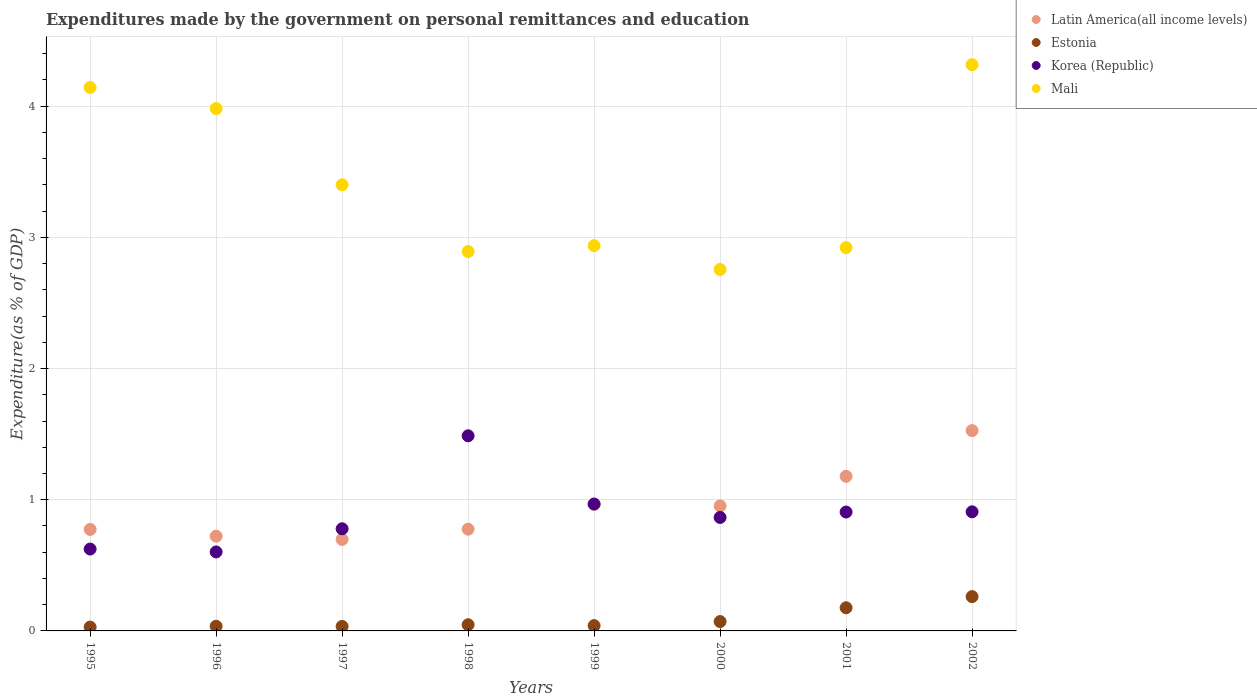How many different coloured dotlines are there?
Make the answer very short. 4. Is the number of dotlines equal to the number of legend labels?
Provide a short and direct response. Yes. What is the expenditures made by the government on personal remittances and education in Estonia in 1996?
Provide a short and direct response. 0.04. Across all years, what is the maximum expenditures made by the government on personal remittances and education in Mali?
Offer a terse response. 4.32. Across all years, what is the minimum expenditures made by the government on personal remittances and education in Estonia?
Ensure brevity in your answer.  0.03. In which year was the expenditures made by the government on personal remittances and education in Estonia minimum?
Offer a very short reply. 1995. What is the total expenditures made by the government on personal remittances and education in Estonia in the graph?
Your answer should be very brief. 0.7. What is the difference between the expenditures made by the government on personal remittances and education in Mali in 1999 and that in 2000?
Your response must be concise. 0.18. What is the difference between the expenditures made by the government on personal remittances and education in Estonia in 2002 and the expenditures made by the government on personal remittances and education in Mali in 1999?
Your response must be concise. -2.68. What is the average expenditures made by the government on personal remittances and education in Korea (Republic) per year?
Give a very brief answer. 0.89. In the year 1996, what is the difference between the expenditures made by the government on personal remittances and education in Latin America(all income levels) and expenditures made by the government on personal remittances and education in Estonia?
Your response must be concise. 0.69. In how many years, is the expenditures made by the government on personal remittances and education in Mali greater than 2.8 %?
Make the answer very short. 7. What is the ratio of the expenditures made by the government on personal remittances and education in Mali in 1996 to that in 2002?
Make the answer very short. 0.92. What is the difference between the highest and the second highest expenditures made by the government on personal remittances and education in Korea (Republic)?
Offer a terse response. 0.52. What is the difference between the highest and the lowest expenditures made by the government on personal remittances and education in Estonia?
Provide a succinct answer. 0.23. Is it the case that in every year, the sum of the expenditures made by the government on personal remittances and education in Korea (Republic) and expenditures made by the government on personal remittances and education in Mali  is greater than the sum of expenditures made by the government on personal remittances and education in Latin America(all income levels) and expenditures made by the government on personal remittances and education in Estonia?
Ensure brevity in your answer.  Yes. Does the expenditures made by the government on personal remittances and education in Korea (Republic) monotonically increase over the years?
Provide a short and direct response. No. Is the expenditures made by the government on personal remittances and education in Estonia strictly greater than the expenditures made by the government on personal remittances and education in Korea (Republic) over the years?
Give a very brief answer. No. How many years are there in the graph?
Your answer should be very brief. 8. What is the difference between two consecutive major ticks on the Y-axis?
Offer a terse response. 1. Does the graph contain grids?
Provide a short and direct response. Yes. Where does the legend appear in the graph?
Your response must be concise. Top right. How many legend labels are there?
Provide a short and direct response. 4. What is the title of the graph?
Your answer should be compact. Expenditures made by the government on personal remittances and education. Does "Libya" appear as one of the legend labels in the graph?
Offer a terse response. No. What is the label or title of the Y-axis?
Offer a terse response. Expenditure(as % of GDP). What is the Expenditure(as % of GDP) of Latin America(all income levels) in 1995?
Give a very brief answer. 0.77. What is the Expenditure(as % of GDP) of Estonia in 1995?
Offer a very short reply. 0.03. What is the Expenditure(as % of GDP) in Korea (Republic) in 1995?
Give a very brief answer. 0.62. What is the Expenditure(as % of GDP) in Mali in 1995?
Your answer should be compact. 4.14. What is the Expenditure(as % of GDP) of Latin America(all income levels) in 1996?
Give a very brief answer. 0.72. What is the Expenditure(as % of GDP) of Estonia in 1996?
Your response must be concise. 0.04. What is the Expenditure(as % of GDP) in Korea (Republic) in 1996?
Your answer should be very brief. 0.6. What is the Expenditure(as % of GDP) of Mali in 1996?
Provide a short and direct response. 3.98. What is the Expenditure(as % of GDP) of Latin America(all income levels) in 1997?
Your answer should be compact. 0.7. What is the Expenditure(as % of GDP) of Estonia in 1997?
Your answer should be compact. 0.03. What is the Expenditure(as % of GDP) of Korea (Republic) in 1997?
Provide a succinct answer. 0.78. What is the Expenditure(as % of GDP) of Mali in 1997?
Offer a very short reply. 3.4. What is the Expenditure(as % of GDP) in Latin America(all income levels) in 1998?
Give a very brief answer. 0.78. What is the Expenditure(as % of GDP) of Estonia in 1998?
Provide a short and direct response. 0.05. What is the Expenditure(as % of GDP) in Korea (Republic) in 1998?
Keep it short and to the point. 1.49. What is the Expenditure(as % of GDP) of Mali in 1998?
Give a very brief answer. 2.89. What is the Expenditure(as % of GDP) in Latin America(all income levels) in 1999?
Your answer should be compact. 0.96. What is the Expenditure(as % of GDP) of Estonia in 1999?
Provide a short and direct response. 0.04. What is the Expenditure(as % of GDP) of Korea (Republic) in 1999?
Ensure brevity in your answer.  0.97. What is the Expenditure(as % of GDP) of Mali in 1999?
Keep it short and to the point. 2.94. What is the Expenditure(as % of GDP) in Latin America(all income levels) in 2000?
Offer a very short reply. 0.95. What is the Expenditure(as % of GDP) of Estonia in 2000?
Offer a very short reply. 0.07. What is the Expenditure(as % of GDP) of Korea (Republic) in 2000?
Your answer should be very brief. 0.86. What is the Expenditure(as % of GDP) in Mali in 2000?
Make the answer very short. 2.76. What is the Expenditure(as % of GDP) of Latin America(all income levels) in 2001?
Your answer should be compact. 1.18. What is the Expenditure(as % of GDP) of Estonia in 2001?
Offer a very short reply. 0.18. What is the Expenditure(as % of GDP) in Korea (Republic) in 2001?
Give a very brief answer. 0.91. What is the Expenditure(as % of GDP) of Mali in 2001?
Provide a succinct answer. 2.92. What is the Expenditure(as % of GDP) in Latin America(all income levels) in 2002?
Provide a succinct answer. 1.53. What is the Expenditure(as % of GDP) in Estonia in 2002?
Offer a terse response. 0.26. What is the Expenditure(as % of GDP) of Korea (Republic) in 2002?
Your answer should be compact. 0.91. What is the Expenditure(as % of GDP) of Mali in 2002?
Provide a succinct answer. 4.32. Across all years, what is the maximum Expenditure(as % of GDP) of Latin America(all income levels)?
Offer a terse response. 1.53. Across all years, what is the maximum Expenditure(as % of GDP) in Estonia?
Your answer should be compact. 0.26. Across all years, what is the maximum Expenditure(as % of GDP) in Korea (Republic)?
Provide a succinct answer. 1.49. Across all years, what is the maximum Expenditure(as % of GDP) of Mali?
Make the answer very short. 4.32. Across all years, what is the minimum Expenditure(as % of GDP) of Latin America(all income levels)?
Provide a short and direct response. 0.7. Across all years, what is the minimum Expenditure(as % of GDP) of Estonia?
Your answer should be compact. 0.03. Across all years, what is the minimum Expenditure(as % of GDP) of Korea (Republic)?
Provide a succinct answer. 0.6. Across all years, what is the minimum Expenditure(as % of GDP) in Mali?
Your response must be concise. 2.76. What is the total Expenditure(as % of GDP) of Latin America(all income levels) in the graph?
Keep it short and to the point. 7.59. What is the total Expenditure(as % of GDP) in Estonia in the graph?
Provide a succinct answer. 0.7. What is the total Expenditure(as % of GDP) in Korea (Republic) in the graph?
Make the answer very short. 7.14. What is the total Expenditure(as % of GDP) in Mali in the graph?
Your response must be concise. 27.35. What is the difference between the Expenditure(as % of GDP) of Latin America(all income levels) in 1995 and that in 1996?
Provide a short and direct response. 0.05. What is the difference between the Expenditure(as % of GDP) of Estonia in 1995 and that in 1996?
Your answer should be compact. -0.01. What is the difference between the Expenditure(as % of GDP) in Korea (Republic) in 1995 and that in 1996?
Offer a very short reply. 0.02. What is the difference between the Expenditure(as % of GDP) of Mali in 1995 and that in 1996?
Offer a terse response. 0.16. What is the difference between the Expenditure(as % of GDP) in Latin America(all income levels) in 1995 and that in 1997?
Give a very brief answer. 0.08. What is the difference between the Expenditure(as % of GDP) in Estonia in 1995 and that in 1997?
Your response must be concise. -0. What is the difference between the Expenditure(as % of GDP) of Korea (Republic) in 1995 and that in 1997?
Offer a very short reply. -0.15. What is the difference between the Expenditure(as % of GDP) of Mali in 1995 and that in 1997?
Provide a succinct answer. 0.74. What is the difference between the Expenditure(as % of GDP) of Latin America(all income levels) in 1995 and that in 1998?
Provide a short and direct response. -0. What is the difference between the Expenditure(as % of GDP) in Estonia in 1995 and that in 1998?
Your response must be concise. -0.02. What is the difference between the Expenditure(as % of GDP) of Korea (Republic) in 1995 and that in 1998?
Give a very brief answer. -0.86. What is the difference between the Expenditure(as % of GDP) of Mali in 1995 and that in 1998?
Make the answer very short. 1.25. What is the difference between the Expenditure(as % of GDP) of Latin America(all income levels) in 1995 and that in 1999?
Your answer should be very brief. -0.19. What is the difference between the Expenditure(as % of GDP) in Estonia in 1995 and that in 1999?
Provide a short and direct response. -0.01. What is the difference between the Expenditure(as % of GDP) in Korea (Republic) in 1995 and that in 1999?
Provide a short and direct response. -0.34. What is the difference between the Expenditure(as % of GDP) of Mali in 1995 and that in 1999?
Ensure brevity in your answer.  1.21. What is the difference between the Expenditure(as % of GDP) of Latin America(all income levels) in 1995 and that in 2000?
Give a very brief answer. -0.18. What is the difference between the Expenditure(as % of GDP) in Estonia in 1995 and that in 2000?
Your answer should be very brief. -0.04. What is the difference between the Expenditure(as % of GDP) in Korea (Republic) in 1995 and that in 2000?
Ensure brevity in your answer.  -0.24. What is the difference between the Expenditure(as % of GDP) of Mali in 1995 and that in 2000?
Provide a short and direct response. 1.39. What is the difference between the Expenditure(as % of GDP) in Latin America(all income levels) in 1995 and that in 2001?
Ensure brevity in your answer.  -0.4. What is the difference between the Expenditure(as % of GDP) in Estonia in 1995 and that in 2001?
Keep it short and to the point. -0.15. What is the difference between the Expenditure(as % of GDP) of Korea (Republic) in 1995 and that in 2001?
Make the answer very short. -0.28. What is the difference between the Expenditure(as % of GDP) of Mali in 1995 and that in 2001?
Ensure brevity in your answer.  1.22. What is the difference between the Expenditure(as % of GDP) of Latin America(all income levels) in 1995 and that in 2002?
Provide a short and direct response. -0.75. What is the difference between the Expenditure(as % of GDP) of Estonia in 1995 and that in 2002?
Your answer should be compact. -0.23. What is the difference between the Expenditure(as % of GDP) of Korea (Republic) in 1995 and that in 2002?
Give a very brief answer. -0.28. What is the difference between the Expenditure(as % of GDP) in Mali in 1995 and that in 2002?
Provide a short and direct response. -0.17. What is the difference between the Expenditure(as % of GDP) of Latin America(all income levels) in 1996 and that in 1997?
Your answer should be compact. 0.02. What is the difference between the Expenditure(as % of GDP) of Estonia in 1996 and that in 1997?
Offer a terse response. 0. What is the difference between the Expenditure(as % of GDP) in Korea (Republic) in 1996 and that in 1997?
Make the answer very short. -0.18. What is the difference between the Expenditure(as % of GDP) in Mali in 1996 and that in 1997?
Give a very brief answer. 0.58. What is the difference between the Expenditure(as % of GDP) of Latin America(all income levels) in 1996 and that in 1998?
Ensure brevity in your answer.  -0.05. What is the difference between the Expenditure(as % of GDP) in Estonia in 1996 and that in 1998?
Keep it short and to the point. -0.01. What is the difference between the Expenditure(as % of GDP) in Korea (Republic) in 1996 and that in 1998?
Provide a short and direct response. -0.89. What is the difference between the Expenditure(as % of GDP) of Mali in 1996 and that in 1998?
Your response must be concise. 1.09. What is the difference between the Expenditure(as % of GDP) of Latin America(all income levels) in 1996 and that in 1999?
Offer a terse response. -0.24. What is the difference between the Expenditure(as % of GDP) of Estonia in 1996 and that in 1999?
Your answer should be very brief. -0. What is the difference between the Expenditure(as % of GDP) in Korea (Republic) in 1996 and that in 1999?
Offer a very short reply. -0.37. What is the difference between the Expenditure(as % of GDP) of Mali in 1996 and that in 1999?
Give a very brief answer. 1.05. What is the difference between the Expenditure(as % of GDP) in Latin America(all income levels) in 1996 and that in 2000?
Provide a short and direct response. -0.23. What is the difference between the Expenditure(as % of GDP) in Estonia in 1996 and that in 2000?
Offer a very short reply. -0.04. What is the difference between the Expenditure(as % of GDP) in Korea (Republic) in 1996 and that in 2000?
Offer a terse response. -0.26. What is the difference between the Expenditure(as % of GDP) in Mali in 1996 and that in 2000?
Provide a short and direct response. 1.23. What is the difference between the Expenditure(as % of GDP) of Latin America(all income levels) in 1996 and that in 2001?
Your response must be concise. -0.46. What is the difference between the Expenditure(as % of GDP) of Estonia in 1996 and that in 2001?
Provide a short and direct response. -0.14. What is the difference between the Expenditure(as % of GDP) in Korea (Republic) in 1996 and that in 2001?
Your response must be concise. -0.3. What is the difference between the Expenditure(as % of GDP) in Mali in 1996 and that in 2001?
Offer a very short reply. 1.06. What is the difference between the Expenditure(as % of GDP) of Latin America(all income levels) in 1996 and that in 2002?
Offer a very short reply. -0.8. What is the difference between the Expenditure(as % of GDP) of Estonia in 1996 and that in 2002?
Give a very brief answer. -0.23. What is the difference between the Expenditure(as % of GDP) in Korea (Republic) in 1996 and that in 2002?
Your answer should be compact. -0.31. What is the difference between the Expenditure(as % of GDP) in Mali in 1996 and that in 2002?
Provide a short and direct response. -0.33. What is the difference between the Expenditure(as % of GDP) in Latin America(all income levels) in 1997 and that in 1998?
Your answer should be very brief. -0.08. What is the difference between the Expenditure(as % of GDP) of Estonia in 1997 and that in 1998?
Your response must be concise. -0.01. What is the difference between the Expenditure(as % of GDP) in Korea (Republic) in 1997 and that in 1998?
Offer a terse response. -0.71. What is the difference between the Expenditure(as % of GDP) in Mali in 1997 and that in 1998?
Your answer should be very brief. 0.51. What is the difference between the Expenditure(as % of GDP) of Latin America(all income levels) in 1997 and that in 1999?
Make the answer very short. -0.27. What is the difference between the Expenditure(as % of GDP) in Estonia in 1997 and that in 1999?
Offer a terse response. -0.01. What is the difference between the Expenditure(as % of GDP) of Korea (Republic) in 1997 and that in 1999?
Offer a very short reply. -0.19. What is the difference between the Expenditure(as % of GDP) in Mali in 1997 and that in 1999?
Offer a terse response. 0.46. What is the difference between the Expenditure(as % of GDP) in Latin America(all income levels) in 1997 and that in 2000?
Keep it short and to the point. -0.26. What is the difference between the Expenditure(as % of GDP) in Estonia in 1997 and that in 2000?
Provide a short and direct response. -0.04. What is the difference between the Expenditure(as % of GDP) of Korea (Republic) in 1997 and that in 2000?
Offer a very short reply. -0.09. What is the difference between the Expenditure(as % of GDP) in Mali in 1997 and that in 2000?
Give a very brief answer. 0.65. What is the difference between the Expenditure(as % of GDP) of Latin America(all income levels) in 1997 and that in 2001?
Give a very brief answer. -0.48. What is the difference between the Expenditure(as % of GDP) in Estonia in 1997 and that in 2001?
Your answer should be very brief. -0.14. What is the difference between the Expenditure(as % of GDP) in Korea (Republic) in 1997 and that in 2001?
Provide a succinct answer. -0.13. What is the difference between the Expenditure(as % of GDP) in Mali in 1997 and that in 2001?
Ensure brevity in your answer.  0.48. What is the difference between the Expenditure(as % of GDP) in Latin America(all income levels) in 1997 and that in 2002?
Provide a succinct answer. -0.83. What is the difference between the Expenditure(as % of GDP) in Estonia in 1997 and that in 2002?
Provide a short and direct response. -0.23. What is the difference between the Expenditure(as % of GDP) of Korea (Republic) in 1997 and that in 2002?
Make the answer very short. -0.13. What is the difference between the Expenditure(as % of GDP) of Mali in 1997 and that in 2002?
Your answer should be very brief. -0.92. What is the difference between the Expenditure(as % of GDP) of Latin America(all income levels) in 1998 and that in 1999?
Provide a succinct answer. -0.19. What is the difference between the Expenditure(as % of GDP) of Estonia in 1998 and that in 1999?
Offer a terse response. 0.01. What is the difference between the Expenditure(as % of GDP) in Korea (Republic) in 1998 and that in 1999?
Keep it short and to the point. 0.52. What is the difference between the Expenditure(as % of GDP) of Mali in 1998 and that in 1999?
Your response must be concise. -0.04. What is the difference between the Expenditure(as % of GDP) in Latin America(all income levels) in 1998 and that in 2000?
Your answer should be compact. -0.18. What is the difference between the Expenditure(as % of GDP) in Estonia in 1998 and that in 2000?
Your answer should be compact. -0.02. What is the difference between the Expenditure(as % of GDP) in Korea (Republic) in 1998 and that in 2000?
Your answer should be compact. 0.62. What is the difference between the Expenditure(as % of GDP) in Mali in 1998 and that in 2000?
Ensure brevity in your answer.  0.14. What is the difference between the Expenditure(as % of GDP) of Latin America(all income levels) in 1998 and that in 2001?
Your answer should be very brief. -0.4. What is the difference between the Expenditure(as % of GDP) in Estonia in 1998 and that in 2001?
Offer a terse response. -0.13. What is the difference between the Expenditure(as % of GDP) of Korea (Republic) in 1998 and that in 2001?
Give a very brief answer. 0.58. What is the difference between the Expenditure(as % of GDP) in Mali in 1998 and that in 2001?
Ensure brevity in your answer.  -0.03. What is the difference between the Expenditure(as % of GDP) in Latin America(all income levels) in 1998 and that in 2002?
Your response must be concise. -0.75. What is the difference between the Expenditure(as % of GDP) of Estonia in 1998 and that in 2002?
Your response must be concise. -0.21. What is the difference between the Expenditure(as % of GDP) in Korea (Republic) in 1998 and that in 2002?
Your answer should be very brief. 0.58. What is the difference between the Expenditure(as % of GDP) in Mali in 1998 and that in 2002?
Ensure brevity in your answer.  -1.42. What is the difference between the Expenditure(as % of GDP) of Latin America(all income levels) in 1999 and that in 2000?
Your response must be concise. 0.01. What is the difference between the Expenditure(as % of GDP) of Estonia in 1999 and that in 2000?
Keep it short and to the point. -0.03. What is the difference between the Expenditure(as % of GDP) in Korea (Republic) in 1999 and that in 2000?
Offer a very short reply. 0.1. What is the difference between the Expenditure(as % of GDP) of Mali in 1999 and that in 2000?
Ensure brevity in your answer.  0.18. What is the difference between the Expenditure(as % of GDP) of Latin America(all income levels) in 1999 and that in 2001?
Your answer should be compact. -0.21. What is the difference between the Expenditure(as % of GDP) in Estonia in 1999 and that in 2001?
Your answer should be very brief. -0.14. What is the difference between the Expenditure(as % of GDP) in Korea (Republic) in 1999 and that in 2001?
Give a very brief answer. 0.06. What is the difference between the Expenditure(as % of GDP) of Mali in 1999 and that in 2001?
Make the answer very short. 0.02. What is the difference between the Expenditure(as % of GDP) in Latin America(all income levels) in 1999 and that in 2002?
Give a very brief answer. -0.56. What is the difference between the Expenditure(as % of GDP) of Estonia in 1999 and that in 2002?
Ensure brevity in your answer.  -0.22. What is the difference between the Expenditure(as % of GDP) of Korea (Republic) in 1999 and that in 2002?
Provide a succinct answer. 0.06. What is the difference between the Expenditure(as % of GDP) of Mali in 1999 and that in 2002?
Your response must be concise. -1.38. What is the difference between the Expenditure(as % of GDP) of Latin America(all income levels) in 2000 and that in 2001?
Provide a succinct answer. -0.23. What is the difference between the Expenditure(as % of GDP) in Estonia in 2000 and that in 2001?
Provide a short and direct response. -0.11. What is the difference between the Expenditure(as % of GDP) of Korea (Republic) in 2000 and that in 2001?
Provide a succinct answer. -0.04. What is the difference between the Expenditure(as % of GDP) of Mali in 2000 and that in 2001?
Give a very brief answer. -0.17. What is the difference between the Expenditure(as % of GDP) of Latin America(all income levels) in 2000 and that in 2002?
Offer a terse response. -0.57. What is the difference between the Expenditure(as % of GDP) of Estonia in 2000 and that in 2002?
Your response must be concise. -0.19. What is the difference between the Expenditure(as % of GDP) in Korea (Republic) in 2000 and that in 2002?
Offer a very short reply. -0.04. What is the difference between the Expenditure(as % of GDP) in Mali in 2000 and that in 2002?
Offer a very short reply. -1.56. What is the difference between the Expenditure(as % of GDP) in Latin America(all income levels) in 2001 and that in 2002?
Your answer should be very brief. -0.35. What is the difference between the Expenditure(as % of GDP) of Estonia in 2001 and that in 2002?
Give a very brief answer. -0.09. What is the difference between the Expenditure(as % of GDP) in Korea (Republic) in 2001 and that in 2002?
Provide a short and direct response. -0. What is the difference between the Expenditure(as % of GDP) in Mali in 2001 and that in 2002?
Offer a very short reply. -1.39. What is the difference between the Expenditure(as % of GDP) of Latin America(all income levels) in 1995 and the Expenditure(as % of GDP) of Estonia in 1996?
Give a very brief answer. 0.74. What is the difference between the Expenditure(as % of GDP) in Latin America(all income levels) in 1995 and the Expenditure(as % of GDP) in Korea (Republic) in 1996?
Your response must be concise. 0.17. What is the difference between the Expenditure(as % of GDP) in Latin America(all income levels) in 1995 and the Expenditure(as % of GDP) in Mali in 1996?
Ensure brevity in your answer.  -3.21. What is the difference between the Expenditure(as % of GDP) of Estonia in 1995 and the Expenditure(as % of GDP) of Korea (Republic) in 1996?
Ensure brevity in your answer.  -0.57. What is the difference between the Expenditure(as % of GDP) of Estonia in 1995 and the Expenditure(as % of GDP) of Mali in 1996?
Provide a succinct answer. -3.95. What is the difference between the Expenditure(as % of GDP) in Korea (Republic) in 1995 and the Expenditure(as % of GDP) in Mali in 1996?
Keep it short and to the point. -3.36. What is the difference between the Expenditure(as % of GDP) in Latin America(all income levels) in 1995 and the Expenditure(as % of GDP) in Estonia in 1997?
Ensure brevity in your answer.  0.74. What is the difference between the Expenditure(as % of GDP) of Latin America(all income levels) in 1995 and the Expenditure(as % of GDP) of Korea (Republic) in 1997?
Make the answer very short. -0. What is the difference between the Expenditure(as % of GDP) of Latin America(all income levels) in 1995 and the Expenditure(as % of GDP) of Mali in 1997?
Make the answer very short. -2.63. What is the difference between the Expenditure(as % of GDP) in Estonia in 1995 and the Expenditure(as % of GDP) in Korea (Republic) in 1997?
Ensure brevity in your answer.  -0.75. What is the difference between the Expenditure(as % of GDP) of Estonia in 1995 and the Expenditure(as % of GDP) of Mali in 1997?
Provide a succinct answer. -3.37. What is the difference between the Expenditure(as % of GDP) of Korea (Republic) in 1995 and the Expenditure(as % of GDP) of Mali in 1997?
Your response must be concise. -2.78. What is the difference between the Expenditure(as % of GDP) of Latin America(all income levels) in 1995 and the Expenditure(as % of GDP) of Estonia in 1998?
Ensure brevity in your answer.  0.73. What is the difference between the Expenditure(as % of GDP) of Latin America(all income levels) in 1995 and the Expenditure(as % of GDP) of Korea (Republic) in 1998?
Your answer should be compact. -0.71. What is the difference between the Expenditure(as % of GDP) of Latin America(all income levels) in 1995 and the Expenditure(as % of GDP) of Mali in 1998?
Your answer should be compact. -2.12. What is the difference between the Expenditure(as % of GDP) of Estonia in 1995 and the Expenditure(as % of GDP) of Korea (Republic) in 1998?
Your answer should be very brief. -1.46. What is the difference between the Expenditure(as % of GDP) of Estonia in 1995 and the Expenditure(as % of GDP) of Mali in 1998?
Your answer should be very brief. -2.86. What is the difference between the Expenditure(as % of GDP) in Korea (Republic) in 1995 and the Expenditure(as % of GDP) in Mali in 1998?
Offer a very short reply. -2.27. What is the difference between the Expenditure(as % of GDP) of Latin America(all income levels) in 1995 and the Expenditure(as % of GDP) of Estonia in 1999?
Offer a terse response. 0.73. What is the difference between the Expenditure(as % of GDP) of Latin America(all income levels) in 1995 and the Expenditure(as % of GDP) of Korea (Republic) in 1999?
Provide a short and direct response. -0.19. What is the difference between the Expenditure(as % of GDP) of Latin America(all income levels) in 1995 and the Expenditure(as % of GDP) of Mali in 1999?
Give a very brief answer. -2.16. What is the difference between the Expenditure(as % of GDP) of Estonia in 1995 and the Expenditure(as % of GDP) of Korea (Republic) in 1999?
Offer a terse response. -0.94. What is the difference between the Expenditure(as % of GDP) in Estonia in 1995 and the Expenditure(as % of GDP) in Mali in 1999?
Your answer should be very brief. -2.91. What is the difference between the Expenditure(as % of GDP) in Korea (Republic) in 1995 and the Expenditure(as % of GDP) in Mali in 1999?
Provide a short and direct response. -2.31. What is the difference between the Expenditure(as % of GDP) of Latin America(all income levels) in 1995 and the Expenditure(as % of GDP) of Estonia in 2000?
Your response must be concise. 0.7. What is the difference between the Expenditure(as % of GDP) in Latin America(all income levels) in 1995 and the Expenditure(as % of GDP) in Korea (Republic) in 2000?
Offer a very short reply. -0.09. What is the difference between the Expenditure(as % of GDP) in Latin America(all income levels) in 1995 and the Expenditure(as % of GDP) in Mali in 2000?
Make the answer very short. -1.98. What is the difference between the Expenditure(as % of GDP) in Estonia in 1995 and the Expenditure(as % of GDP) in Korea (Republic) in 2000?
Your answer should be very brief. -0.84. What is the difference between the Expenditure(as % of GDP) in Estonia in 1995 and the Expenditure(as % of GDP) in Mali in 2000?
Provide a short and direct response. -2.73. What is the difference between the Expenditure(as % of GDP) in Korea (Republic) in 1995 and the Expenditure(as % of GDP) in Mali in 2000?
Offer a terse response. -2.13. What is the difference between the Expenditure(as % of GDP) in Latin America(all income levels) in 1995 and the Expenditure(as % of GDP) in Estonia in 2001?
Offer a very short reply. 0.6. What is the difference between the Expenditure(as % of GDP) in Latin America(all income levels) in 1995 and the Expenditure(as % of GDP) in Korea (Republic) in 2001?
Your answer should be compact. -0.13. What is the difference between the Expenditure(as % of GDP) in Latin America(all income levels) in 1995 and the Expenditure(as % of GDP) in Mali in 2001?
Provide a short and direct response. -2.15. What is the difference between the Expenditure(as % of GDP) in Estonia in 1995 and the Expenditure(as % of GDP) in Korea (Republic) in 2001?
Provide a short and direct response. -0.88. What is the difference between the Expenditure(as % of GDP) in Estonia in 1995 and the Expenditure(as % of GDP) in Mali in 2001?
Offer a terse response. -2.89. What is the difference between the Expenditure(as % of GDP) in Korea (Republic) in 1995 and the Expenditure(as % of GDP) in Mali in 2001?
Offer a very short reply. -2.3. What is the difference between the Expenditure(as % of GDP) of Latin America(all income levels) in 1995 and the Expenditure(as % of GDP) of Estonia in 2002?
Ensure brevity in your answer.  0.51. What is the difference between the Expenditure(as % of GDP) of Latin America(all income levels) in 1995 and the Expenditure(as % of GDP) of Korea (Republic) in 2002?
Offer a terse response. -0.13. What is the difference between the Expenditure(as % of GDP) of Latin America(all income levels) in 1995 and the Expenditure(as % of GDP) of Mali in 2002?
Make the answer very short. -3.54. What is the difference between the Expenditure(as % of GDP) of Estonia in 1995 and the Expenditure(as % of GDP) of Korea (Republic) in 2002?
Make the answer very short. -0.88. What is the difference between the Expenditure(as % of GDP) in Estonia in 1995 and the Expenditure(as % of GDP) in Mali in 2002?
Give a very brief answer. -4.29. What is the difference between the Expenditure(as % of GDP) of Korea (Republic) in 1995 and the Expenditure(as % of GDP) of Mali in 2002?
Ensure brevity in your answer.  -3.69. What is the difference between the Expenditure(as % of GDP) of Latin America(all income levels) in 1996 and the Expenditure(as % of GDP) of Estonia in 1997?
Offer a terse response. 0.69. What is the difference between the Expenditure(as % of GDP) of Latin America(all income levels) in 1996 and the Expenditure(as % of GDP) of Korea (Republic) in 1997?
Give a very brief answer. -0.06. What is the difference between the Expenditure(as % of GDP) in Latin America(all income levels) in 1996 and the Expenditure(as % of GDP) in Mali in 1997?
Your answer should be compact. -2.68. What is the difference between the Expenditure(as % of GDP) in Estonia in 1996 and the Expenditure(as % of GDP) in Korea (Republic) in 1997?
Make the answer very short. -0.74. What is the difference between the Expenditure(as % of GDP) of Estonia in 1996 and the Expenditure(as % of GDP) of Mali in 1997?
Your answer should be very brief. -3.37. What is the difference between the Expenditure(as % of GDP) of Korea (Republic) in 1996 and the Expenditure(as % of GDP) of Mali in 1997?
Ensure brevity in your answer.  -2.8. What is the difference between the Expenditure(as % of GDP) of Latin America(all income levels) in 1996 and the Expenditure(as % of GDP) of Estonia in 1998?
Your answer should be very brief. 0.68. What is the difference between the Expenditure(as % of GDP) in Latin America(all income levels) in 1996 and the Expenditure(as % of GDP) in Korea (Republic) in 1998?
Your answer should be compact. -0.77. What is the difference between the Expenditure(as % of GDP) in Latin America(all income levels) in 1996 and the Expenditure(as % of GDP) in Mali in 1998?
Provide a short and direct response. -2.17. What is the difference between the Expenditure(as % of GDP) of Estonia in 1996 and the Expenditure(as % of GDP) of Korea (Republic) in 1998?
Give a very brief answer. -1.45. What is the difference between the Expenditure(as % of GDP) of Estonia in 1996 and the Expenditure(as % of GDP) of Mali in 1998?
Provide a short and direct response. -2.86. What is the difference between the Expenditure(as % of GDP) of Korea (Republic) in 1996 and the Expenditure(as % of GDP) of Mali in 1998?
Provide a short and direct response. -2.29. What is the difference between the Expenditure(as % of GDP) of Latin America(all income levels) in 1996 and the Expenditure(as % of GDP) of Estonia in 1999?
Your answer should be compact. 0.68. What is the difference between the Expenditure(as % of GDP) of Latin America(all income levels) in 1996 and the Expenditure(as % of GDP) of Korea (Republic) in 1999?
Offer a terse response. -0.25. What is the difference between the Expenditure(as % of GDP) in Latin America(all income levels) in 1996 and the Expenditure(as % of GDP) in Mali in 1999?
Your answer should be very brief. -2.21. What is the difference between the Expenditure(as % of GDP) of Estonia in 1996 and the Expenditure(as % of GDP) of Korea (Republic) in 1999?
Provide a short and direct response. -0.93. What is the difference between the Expenditure(as % of GDP) of Estonia in 1996 and the Expenditure(as % of GDP) of Mali in 1999?
Your answer should be very brief. -2.9. What is the difference between the Expenditure(as % of GDP) in Korea (Republic) in 1996 and the Expenditure(as % of GDP) in Mali in 1999?
Give a very brief answer. -2.33. What is the difference between the Expenditure(as % of GDP) of Latin America(all income levels) in 1996 and the Expenditure(as % of GDP) of Estonia in 2000?
Keep it short and to the point. 0.65. What is the difference between the Expenditure(as % of GDP) of Latin America(all income levels) in 1996 and the Expenditure(as % of GDP) of Korea (Republic) in 2000?
Your answer should be very brief. -0.14. What is the difference between the Expenditure(as % of GDP) in Latin America(all income levels) in 1996 and the Expenditure(as % of GDP) in Mali in 2000?
Ensure brevity in your answer.  -2.03. What is the difference between the Expenditure(as % of GDP) of Estonia in 1996 and the Expenditure(as % of GDP) of Korea (Republic) in 2000?
Provide a short and direct response. -0.83. What is the difference between the Expenditure(as % of GDP) of Estonia in 1996 and the Expenditure(as % of GDP) of Mali in 2000?
Offer a very short reply. -2.72. What is the difference between the Expenditure(as % of GDP) of Korea (Republic) in 1996 and the Expenditure(as % of GDP) of Mali in 2000?
Make the answer very short. -2.15. What is the difference between the Expenditure(as % of GDP) in Latin America(all income levels) in 1996 and the Expenditure(as % of GDP) in Estonia in 2001?
Make the answer very short. 0.55. What is the difference between the Expenditure(as % of GDP) in Latin America(all income levels) in 1996 and the Expenditure(as % of GDP) in Korea (Republic) in 2001?
Offer a very short reply. -0.18. What is the difference between the Expenditure(as % of GDP) in Latin America(all income levels) in 1996 and the Expenditure(as % of GDP) in Mali in 2001?
Provide a short and direct response. -2.2. What is the difference between the Expenditure(as % of GDP) of Estonia in 1996 and the Expenditure(as % of GDP) of Korea (Republic) in 2001?
Make the answer very short. -0.87. What is the difference between the Expenditure(as % of GDP) in Estonia in 1996 and the Expenditure(as % of GDP) in Mali in 2001?
Keep it short and to the point. -2.89. What is the difference between the Expenditure(as % of GDP) in Korea (Republic) in 1996 and the Expenditure(as % of GDP) in Mali in 2001?
Keep it short and to the point. -2.32. What is the difference between the Expenditure(as % of GDP) of Latin America(all income levels) in 1996 and the Expenditure(as % of GDP) of Estonia in 2002?
Offer a very short reply. 0.46. What is the difference between the Expenditure(as % of GDP) of Latin America(all income levels) in 1996 and the Expenditure(as % of GDP) of Korea (Republic) in 2002?
Offer a very short reply. -0.19. What is the difference between the Expenditure(as % of GDP) of Latin America(all income levels) in 1996 and the Expenditure(as % of GDP) of Mali in 2002?
Your answer should be very brief. -3.59. What is the difference between the Expenditure(as % of GDP) in Estonia in 1996 and the Expenditure(as % of GDP) in Korea (Republic) in 2002?
Give a very brief answer. -0.87. What is the difference between the Expenditure(as % of GDP) of Estonia in 1996 and the Expenditure(as % of GDP) of Mali in 2002?
Make the answer very short. -4.28. What is the difference between the Expenditure(as % of GDP) of Korea (Republic) in 1996 and the Expenditure(as % of GDP) of Mali in 2002?
Offer a very short reply. -3.71. What is the difference between the Expenditure(as % of GDP) of Latin America(all income levels) in 1997 and the Expenditure(as % of GDP) of Estonia in 1998?
Provide a succinct answer. 0.65. What is the difference between the Expenditure(as % of GDP) of Latin America(all income levels) in 1997 and the Expenditure(as % of GDP) of Korea (Republic) in 1998?
Offer a terse response. -0.79. What is the difference between the Expenditure(as % of GDP) in Latin America(all income levels) in 1997 and the Expenditure(as % of GDP) in Mali in 1998?
Provide a succinct answer. -2.19. What is the difference between the Expenditure(as % of GDP) in Estonia in 1997 and the Expenditure(as % of GDP) in Korea (Republic) in 1998?
Give a very brief answer. -1.45. What is the difference between the Expenditure(as % of GDP) in Estonia in 1997 and the Expenditure(as % of GDP) in Mali in 1998?
Make the answer very short. -2.86. What is the difference between the Expenditure(as % of GDP) in Korea (Republic) in 1997 and the Expenditure(as % of GDP) in Mali in 1998?
Provide a short and direct response. -2.11. What is the difference between the Expenditure(as % of GDP) of Latin America(all income levels) in 1997 and the Expenditure(as % of GDP) of Estonia in 1999?
Provide a short and direct response. 0.66. What is the difference between the Expenditure(as % of GDP) in Latin America(all income levels) in 1997 and the Expenditure(as % of GDP) in Korea (Republic) in 1999?
Your answer should be compact. -0.27. What is the difference between the Expenditure(as % of GDP) in Latin America(all income levels) in 1997 and the Expenditure(as % of GDP) in Mali in 1999?
Provide a succinct answer. -2.24. What is the difference between the Expenditure(as % of GDP) in Estonia in 1997 and the Expenditure(as % of GDP) in Korea (Republic) in 1999?
Ensure brevity in your answer.  -0.93. What is the difference between the Expenditure(as % of GDP) in Estonia in 1997 and the Expenditure(as % of GDP) in Mali in 1999?
Your response must be concise. -2.9. What is the difference between the Expenditure(as % of GDP) of Korea (Republic) in 1997 and the Expenditure(as % of GDP) of Mali in 1999?
Offer a terse response. -2.16. What is the difference between the Expenditure(as % of GDP) in Latin America(all income levels) in 1997 and the Expenditure(as % of GDP) in Estonia in 2000?
Make the answer very short. 0.63. What is the difference between the Expenditure(as % of GDP) in Latin America(all income levels) in 1997 and the Expenditure(as % of GDP) in Korea (Republic) in 2000?
Offer a terse response. -0.17. What is the difference between the Expenditure(as % of GDP) of Latin America(all income levels) in 1997 and the Expenditure(as % of GDP) of Mali in 2000?
Give a very brief answer. -2.06. What is the difference between the Expenditure(as % of GDP) of Estonia in 1997 and the Expenditure(as % of GDP) of Korea (Republic) in 2000?
Provide a succinct answer. -0.83. What is the difference between the Expenditure(as % of GDP) in Estonia in 1997 and the Expenditure(as % of GDP) in Mali in 2000?
Give a very brief answer. -2.72. What is the difference between the Expenditure(as % of GDP) of Korea (Republic) in 1997 and the Expenditure(as % of GDP) of Mali in 2000?
Give a very brief answer. -1.98. What is the difference between the Expenditure(as % of GDP) in Latin America(all income levels) in 1997 and the Expenditure(as % of GDP) in Estonia in 2001?
Your answer should be compact. 0.52. What is the difference between the Expenditure(as % of GDP) of Latin America(all income levels) in 1997 and the Expenditure(as % of GDP) of Korea (Republic) in 2001?
Provide a succinct answer. -0.21. What is the difference between the Expenditure(as % of GDP) in Latin America(all income levels) in 1997 and the Expenditure(as % of GDP) in Mali in 2001?
Your response must be concise. -2.22. What is the difference between the Expenditure(as % of GDP) of Estonia in 1997 and the Expenditure(as % of GDP) of Korea (Republic) in 2001?
Ensure brevity in your answer.  -0.87. What is the difference between the Expenditure(as % of GDP) of Estonia in 1997 and the Expenditure(as % of GDP) of Mali in 2001?
Make the answer very short. -2.89. What is the difference between the Expenditure(as % of GDP) in Korea (Republic) in 1997 and the Expenditure(as % of GDP) in Mali in 2001?
Provide a succinct answer. -2.14. What is the difference between the Expenditure(as % of GDP) in Latin America(all income levels) in 1997 and the Expenditure(as % of GDP) in Estonia in 2002?
Give a very brief answer. 0.44. What is the difference between the Expenditure(as % of GDP) in Latin America(all income levels) in 1997 and the Expenditure(as % of GDP) in Korea (Republic) in 2002?
Your answer should be compact. -0.21. What is the difference between the Expenditure(as % of GDP) in Latin America(all income levels) in 1997 and the Expenditure(as % of GDP) in Mali in 2002?
Give a very brief answer. -3.62. What is the difference between the Expenditure(as % of GDP) of Estonia in 1997 and the Expenditure(as % of GDP) of Korea (Republic) in 2002?
Keep it short and to the point. -0.87. What is the difference between the Expenditure(as % of GDP) in Estonia in 1997 and the Expenditure(as % of GDP) in Mali in 2002?
Provide a succinct answer. -4.28. What is the difference between the Expenditure(as % of GDP) of Korea (Republic) in 1997 and the Expenditure(as % of GDP) of Mali in 2002?
Make the answer very short. -3.54. What is the difference between the Expenditure(as % of GDP) in Latin America(all income levels) in 1998 and the Expenditure(as % of GDP) in Estonia in 1999?
Provide a short and direct response. 0.74. What is the difference between the Expenditure(as % of GDP) in Latin America(all income levels) in 1998 and the Expenditure(as % of GDP) in Korea (Republic) in 1999?
Keep it short and to the point. -0.19. What is the difference between the Expenditure(as % of GDP) in Latin America(all income levels) in 1998 and the Expenditure(as % of GDP) in Mali in 1999?
Your answer should be very brief. -2.16. What is the difference between the Expenditure(as % of GDP) in Estonia in 1998 and the Expenditure(as % of GDP) in Korea (Republic) in 1999?
Offer a very short reply. -0.92. What is the difference between the Expenditure(as % of GDP) in Estonia in 1998 and the Expenditure(as % of GDP) in Mali in 1999?
Offer a very short reply. -2.89. What is the difference between the Expenditure(as % of GDP) of Korea (Republic) in 1998 and the Expenditure(as % of GDP) of Mali in 1999?
Provide a succinct answer. -1.45. What is the difference between the Expenditure(as % of GDP) of Latin America(all income levels) in 1998 and the Expenditure(as % of GDP) of Estonia in 2000?
Give a very brief answer. 0.7. What is the difference between the Expenditure(as % of GDP) in Latin America(all income levels) in 1998 and the Expenditure(as % of GDP) in Korea (Republic) in 2000?
Ensure brevity in your answer.  -0.09. What is the difference between the Expenditure(as % of GDP) in Latin America(all income levels) in 1998 and the Expenditure(as % of GDP) in Mali in 2000?
Make the answer very short. -1.98. What is the difference between the Expenditure(as % of GDP) of Estonia in 1998 and the Expenditure(as % of GDP) of Korea (Republic) in 2000?
Give a very brief answer. -0.82. What is the difference between the Expenditure(as % of GDP) of Estonia in 1998 and the Expenditure(as % of GDP) of Mali in 2000?
Provide a succinct answer. -2.71. What is the difference between the Expenditure(as % of GDP) of Korea (Republic) in 1998 and the Expenditure(as % of GDP) of Mali in 2000?
Ensure brevity in your answer.  -1.27. What is the difference between the Expenditure(as % of GDP) of Latin America(all income levels) in 1998 and the Expenditure(as % of GDP) of Estonia in 2001?
Your answer should be very brief. 0.6. What is the difference between the Expenditure(as % of GDP) of Latin America(all income levels) in 1998 and the Expenditure(as % of GDP) of Korea (Republic) in 2001?
Give a very brief answer. -0.13. What is the difference between the Expenditure(as % of GDP) of Latin America(all income levels) in 1998 and the Expenditure(as % of GDP) of Mali in 2001?
Ensure brevity in your answer.  -2.15. What is the difference between the Expenditure(as % of GDP) of Estonia in 1998 and the Expenditure(as % of GDP) of Korea (Republic) in 2001?
Offer a terse response. -0.86. What is the difference between the Expenditure(as % of GDP) in Estonia in 1998 and the Expenditure(as % of GDP) in Mali in 2001?
Provide a succinct answer. -2.87. What is the difference between the Expenditure(as % of GDP) of Korea (Republic) in 1998 and the Expenditure(as % of GDP) of Mali in 2001?
Give a very brief answer. -1.43. What is the difference between the Expenditure(as % of GDP) of Latin America(all income levels) in 1998 and the Expenditure(as % of GDP) of Estonia in 2002?
Your answer should be very brief. 0.51. What is the difference between the Expenditure(as % of GDP) in Latin America(all income levels) in 1998 and the Expenditure(as % of GDP) in Korea (Republic) in 2002?
Provide a short and direct response. -0.13. What is the difference between the Expenditure(as % of GDP) in Latin America(all income levels) in 1998 and the Expenditure(as % of GDP) in Mali in 2002?
Provide a short and direct response. -3.54. What is the difference between the Expenditure(as % of GDP) in Estonia in 1998 and the Expenditure(as % of GDP) in Korea (Republic) in 2002?
Make the answer very short. -0.86. What is the difference between the Expenditure(as % of GDP) in Estonia in 1998 and the Expenditure(as % of GDP) in Mali in 2002?
Provide a succinct answer. -4.27. What is the difference between the Expenditure(as % of GDP) of Korea (Republic) in 1998 and the Expenditure(as % of GDP) of Mali in 2002?
Ensure brevity in your answer.  -2.83. What is the difference between the Expenditure(as % of GDP) in Latin America(all income levels) in 1999 and the Expenditure(as % of GDP) in Estonia in 2000?
Provide a short and direct response. 0.89. What is the difference between the Expenditure(as % of GDP) in Latin America(all income levels) in 1999 and the Expenditure(as % of GDP) in Korea (Republic) in 2000?
Provide a succinct answer. 0.1. What is the difference between the Expenditure(as % of GDP) of Latin America(all income levels) in 1999 and the Expenditure(as % of GDP) of Mali in 2000?
Keep it short and to the point. -1.79. What is the difference between the Expenditure(as % of GDP) of Estonia in 1999 and the Expenditure(as % of GDP) of Korea (Republic) in 2000?
Keep it short and to the point. -0.82. What is the difference between the Expenditure(as % of GDP) in Estonia in 1999 and the Expenditure(as % of GDP) in Mali in 2000?
Provide a succinct answer. -2.71. What is the difference between the Expenditure(as % of GDP) in Korea (Republic) in 1999 and the Expenditure(as % of GDP) in Mali in 2000?
Offer a very short reply. -1.79. What is the difference between the Expenditure(as % of GDP) in Latin America(all income levels) in 1999 and the Expenditure(as % of GDP) in Estonia in 2001?
Your response must be concise. 0.79. What is the difference between the Expenditure(as % of GDP) in Latin America(all income levels) in 1999 and the Expenditure(as % of GDP) in Korea (Republic) in 2001?
Offer a very short reply. 0.06. What is the difference between the Expenditure(as % of GDP) in Latin America(all income levels) in 1999 and the Expenditure(as % of GDP) in Mali in 2001?
Provide a succinct answer. -1.96. What is the difference between the Expenditure(as % of GDP) in Estonia in 1999 and the Expenditure(as % of GDP) in Korea (Republic) in 2001?
Make the answer very short. -0.87. What is the difference between the Expenditure(as % of GDP) of Estonia in 1999 and the Expenditure(as % of GDP) of Mali in 2001?
Ensure brevity in your answer.  -2.88. What is the difference between the Expenditure(as % of GDP) of Korea (Republic) in 1999 and the Expenditure(as % of GDP) of Mali in 2001?
Make the answer very short. -1.95. What is the difference between the Expenditure(as % of GDP) of Latin America(all income levels) in 1999 and the Expenditure(as % of GDP) of Estonia in 2002?
Provide a succinct answer. 0.7. What is the difference between the Expenditure(as % of GDP) of Latin America(all income levels) in 1999 and the Expenditure(as % of GDP) of Korea (Republic) in 2002?
Offer a very short reply. 0.06. What is the difference between the Expenditure(as % of GDP) of Latin America(all income levels) in 1999 and the Expenditure(as % of GDP) of Mali in 2002?
Give a very brief answer. -3.35. What is the difference between the Expenditure(as % of GDP) in Estonia in 1999 and the Expenditure(as % of GDP) in Korea (Republic) in 2002?
Offer a very short reply. -0.87. What is the difference between the Expenditure(as % of GDP) of Estonia in 1999 and the Expenditure(as % of GDP) of Mali in 2002?
Offer a very short reply. -4.28. What is the difference between the Expenditure(as % of GDP) of Korea (Republic) in 1999 and the Expenditure(as % of GDP) of Mali in 2002?
Make the answer very short. -3.35. What is the difference between the Expenditure(as % of GDP) of Latin America(all income levels) in 2000 and the Expenditure(as % of GDP) of Estonia in 2001?
Provide a short and direct response. 0.78. What is the difference between the Expenditure(as % of GDP) of Latin America(all income levels) in 2000 and the Expenditure(as % of GDP) of Korea (Republic) in 2001?
Give a very brief answer. 0.05. What is the difference between the Expenditure(as % of GDP) in Latin America(all income levels) in 2000 and the Expenditure(as % of GDP) in Mali in 2001?
Offer a terse response. -1.97. What is the difference between the Expenditure(as % of GDP) of Estonia in 2000 and the Expenditure(as % of GDP) of Korea (Republic) in 2001?
Ensure brevity in your answer.  -0.84. What is the difference between the Expenditure(as % of GDP) of Estonia in 2000 and the Expenditure(as % of GDP) of Mali in 2001?
Your answer should be very brief. -2.85. What is the difference between the Expenditure(as % of GDP) of Korea (Republic) in 2000 and the Expenditure(as % of GDP) of Mali in 2001?
Your answer should be compact. -2.06. What is the difference between the Expenditure(as % of GDP) in Latin America(all income levels) in 2000 and the Expenditure(as % of GDP) in Estonia in 2002?
Your response must be concise. 0.69. What is the difference between the Expenditure(as % of GDP) in Latin America(all income levels) in 2000 and the Expenditure(as % of GDP) in Korea (Republic) in 2002?
Your answer should be compact. 0.04. What is the difference between the Expenditure(as % of GDP) in Latin America(all income levels) in 2000 and the Expenditure(as % of GDP) in Mali in 2002?
Provide a short and direct response. -3.36. What is the difference between the Expenditure(as % of GDP) of Estonia in 2000 and the Expenditure(as % of GDP) of Korea (Republic) in 2002?
Your answer should be compact. -0.84. What is the difference between the Expenditure(as % of GDP) of Estonia in 2000 and the Expenditure(as % of GDP) of Mali in 2002?
Your answer should be very brief. -4.25. What is the difference between the Expenditure(as % of GDP) of Korea (Republic) in 2000 and the Expenditure(as % of GDP) of Mali in 2002?
Keep it short and to the point. -3.45. What is the difference between the Expenditure(as % of GDP) in Latin America(all income levels) in 2001 and the Expenditure(as % of GDP) in Estonia in 2002?
Offer a terse response. 0.92. What is the difference between the Expenditure(as % of GDP) in Latin America(all income levels) in 2001 and the Expenditure(as % of GDP) in Korea (Republic) in 2002?
Provide a short and direct response. 0.27. What is the difference between the Expenditure(as % of GDP) in Latin America(all income levels) in 2001 and the Expenditure(as % of GDP) in Mali in 2002?
Keep it short and to the point. -3.14. What is the difference between the Expenditure(as % of GDP) in Estonia in 2001 and the Expenditure(as % of GDP) in Korea (Republic) in 2002?
Your answer should be very brief. -0.73. What is the difference between the Expenditure(as % of GDP) in Estonia in 2001 and the Expenditure(as % of GDP) in Mali in 2002?
Offer a terse response. -4.14. What is the difference between the Expenditure(as % of GDP) of Korea (Republic) in 2001 and the Expenditure(as % of GDP) of Mali in 2002?
Offer a very short reply. -3.41. What is the average Expenditure(as % of GDP) in Latin America(all income levels) per year?
Ensure brevity in your answer.  0.95. What is the average Expenditure(as % of GDP) of Estonia per year?
Your response must be concise. 0.09. What is the average Expenditure(as % of GDP) in Korea (Republic) per year?
Ensure brevity in your answer.  0.89. What is the average Expenditure(as % of GDP) in Mali per year?
Provide a short and direct response. 3.42. In the year 1995, what is the difference between the Expenditure(as % of GDP) in Latin America(all income levels) and Expenditure(as % of GDP) in Estonia?
Provide a succinct answer. 0.74. In the year 1995, what is the difference between the Expenditure(as % of GDP) in Latin America(all income levels) and Expenditure(as % of GDP) in Korea (Republic)?
Give a very brief answer. 0.15. In the year 1995, what is the difference between the Expenditure(as % of GDP) in Latin America(all income levels) and Expenditure(as % of GDP) in Mali?
Give a very brief answer. -3.37. In the year 1995, what is the difference between the Expenditure(as % of GDP) in Estonia and Expenditure(as % of GDP) in Korea (Republic)?
Ensure brevity in your answer.  -0.59. In the year 1995, what is the difference between the Expenditure(as % of GDP) in Estonia and Expenditure(as % of GDP) in Mali?
Your answer should be compact. -4.11. In the year 1995, what is the difference between the Expenditure(as % of GDP) of Korea (Republic) and Expenditure(as % of GDP) of Mali?
Make the answer very short. -3.52. In the year 1996, what is the difference between the Expenditure(as % of GDP) of Latin America(all income levels) and Expenditure(as % of GDP) of Estonia?
Your answer should be very brief. 0.69. In the year 1996, what is the difference between the Expenditure(as % of GDP) in Latin America(all income levels) and Expenditure(as % of GDP) in Korea (Republic)?
Your response must be concise. 0.12. In the year 1996, what is the difference between the Expenditure(as % of GDP) in Latin America(all income levels) and Expenditure(as % of GDP) in Mali?
Your answer should be very brief. -3.26. In the year 1996, what is the difference between the Expenditure(as % of GDP) of Estonia and Expenditure(as % of GDP) of Korea (Republic)?
Provide a short and direct response. -0.57. In the year 1996, what is the difference between the Expenditure(as % of GDP) in Estonia and Expenditure(as % of GDP) in Mali?
Keep it short and to the point. -3.95. In the year 1996, what is the difference between the Expenditure(as % of GDP) in Korea (Republic) and Expenditure(as % of GDP) in Mali?
Keep it short and to the point. -3.38. In the year 1997, what is the difference between the Expenditure(as % of GDP) of Latin America(all income levels) and Expenditure(as % of GDP) of Estonia?
Your answer should be compact. 0.66. In the year 1997, what is the difference between the Expenditure(as % of GDP) of Latin America(all income levels) and Expenditure(as % of GDP) of Korea (Republic)?
Your answer should be very brief. -0.08. In the year 1997, what is the difference between the Expenditure(as % of GDP) in Latin America(all income levels) and Expenditure(as % of GDP) in Mali?
Offer a terse response. -2.7. In the year 1997, what is the difference between the Expenditure(as % of GDP) of Estonia and Expenditure(as % of GDP) of Korea (Republic)?
Your answer should be very brief. -0.74. In the year 1997, what is the difference between the Expenditure(as % of GDP) in Estonia and Expenditure(as % of GDP) in Mali?
Offer a terse response. -3.37. In the year 1997, what is the difference between the Expenditure(as % of GDP) in Korea (Republic) and Expenditure(as % of GDP) in Mali?
Offer a very short reply. -2.62. In the year 1998, what is the difference between the Expenditure(as % of GDP) of Latin America(all income levels) and Expenditure(as % of GDP) of Estonia?
Your answer should be compact. 0.73. In the year 1998, what is the difference between the Expenditure(as % of GDP) in Latin America(all income levels) and Expenditure(as % of GDP) in Korea (Republic)?
Make the answer very short. -0.71. In the year 1998, what is the difference between the Expenditure(as % of GDP) of Latin America(all income levels) and Expenditure(as % of GDP) of Mali?
Offer a terse response. -2.12. In the year 1998, what is the difference between the Expenditure(as % of GDP) in Estonia and Expenditure(as % of GDP) in Korea (Republic)?
Make the answer very short. -1.44. In the year 1998, what is the difference between the Expenditure(as % of GDP) in Estonia and Expenditure(as % of GDP) in Mali?
Your answer should be very brief. -2.85. In the year 1998, what is the difference between the Expenditure(as % of GDP) of Korea (Republic) and Expenditure(as % of GDP) of Mali?
Provide a short and direct response. -1.4. In the year 1999, what is the difference between the Expenditure(as % of GDP) of Latin America(all income levels) and Expenditure(as % of GDP) of Estonia?
Provide a succinct answer. 0.92. In the year 1999, what is the difference between the Expenditure(as % of GDP) in Latin America(all income levels) and Expenditure(as % of GDP) in Korea (Republic)?
Keep it short and to the point. -0. In the year 1999, what is the difference between the Expenditure(as % of GDP) of Latin America(all income levels) and Expenditure(as % of GDP) of Mali?
Provide a short and direct response. -1.97. In the year 1999, what is the difference between the Expenditure(as % of GDP) of Estonia and Expenditure(as % of GDP) of Korea (Republic)?
Provide a succinct answer. -0.93. In the year 1999, what is the difference between the Expenditure(as % of GDP) of Estonia and Expenditure(as % of GDP) of Mali?
Give a very brief answer. -2.9. In the year 1999, what is the difference between the Expenditure(as % of GDP) in Korea (Republic) and Expenditure(as % of GDP) in Mali?
Your answer should be compact. -1.97. In the year 2000, what is the difference between the Expenditure(as % of GDP) of Latin America(all income levels) and Expenditure(as % of GDP) of Estonia?
Your answer should be compact. 0.88. In the year 2000, what is the difference between the Expenditure(as % of GDP) in Latin America(all income levels) and Expenditure(as % of GDP) in Korea (Republic)?
Provide a succinct answer. 0.09. In the year 2000, what is the difference between the Expenditure(as % of GDP) of Latin America(all income levels) and Expenditure(as % of GDP) of Mali?
Your answer should be very brief. -1.8. In the year 2000, what is the difference between the Expenditure(as % of GDP) in Estonia and Expenditure(as % of GDP) in Korea (Republic)?
Make the answer very short. -0.79. In the year 2000, what is the difference between the Expenditure(as % of GDP) in Estonia and Expenditure(as % of GDP) in Mali?
Your answer should be compact. -2.68. In the year 2000, what is the difference between the Expenditure(as % of GDP) of Korea (Republic) and Expenditure(as % of GDP) of Mali?
Make the answer very short. -1.89. In the year 2001, what is the difference between the Expenditure(as % of GDP) in Latin America(all income levels) and Expenditure(as % of GDP) in Estonia?
Provide a succinct answer. 1. In the year 2001, what is the difference between the Expenditure(as % of GDP) of Latin America(all income levels) and Expenditure(as % of GDP) of Korea (Republic)?
Your answer should be compact. 0.27. In the year 2001, what is the difference between the Expenditure(as % of GDP) in Latin America(all income levels) and Expenditure(as % of GDP) in Mali?
Provide a short and direct response. -1.74. In the year 2001, what is the difference between the Expenditure(as % of GDP) of Estonia and Expenditure(as % of GDP) of Korea (Republic)?
Your answer should be compact. -0.73. In the year 2001, what is the difference between the Expenditure(as % of GDP) of Estonia and Expenditure(as % of GDP) of Mali?
Your answer should be very brief. -2.75. In the year 2001, what is the difference between the Expenditure(as % of GDP) in Korea (Republic) and Expenditure(as % of GDP) in Mali?
Your answer should be compact. -2.02. In the year 2002, what is the difference between the Expenditure(as % of GDP) in Latin America(all income levels) and Expenditure(as % of GDP) in Estonia?
Provide a short and direct response. 1.27. In the year 2002, what is the difference between the Expenditure(as % of GDP) in Latin America(all income levels) and Expenditure(as % of GDP) in Korea (Republic)?
Offer a terse response. 0.62. In the year 2002, what is the difference between the Expenditure(as % of GDP) of Latin America(all income levels) and Expenditure(as % of GDP) of Mali?
Your answer should be very brief. -2.79. In the year 2002, what is the difference between the Expenditure(as % of GDP) in Estonia and Expenditure(as % of GDP) in Korea (Republic)?
Your answer should be very brief. -0.65. In the year 2002, what is the difference between the Expenditure(as % of GDP) of Estonia and Expenditure(as % of GDP) of Mali?
Keep it short and to the point. -4.05. In the year 2002, what is the difference between the Expenditure(as % of GDP) of Korea (Republic) and Expenditure(as % of GDP) of Mali?
Your response must be concise. -3.41. What is the ratio of the Expenditure(as % of GDP) of Latin America(all income levels) in 1995 to that in 1996?
Your answer should be very brief. 1.07. What is the ratio of the Expenditure(as % of GDP) of Estonia in 1995 to that in 1996?
Make the answer very short. 0.83. What is the ratio of the Expenditure(as % of GDP) in Korea (Republic) in 1995 to that in 1996?
Offer a terse response. 1.04. What is the ratio of the Expenditure(as % of GDP) in Mali in 1995 to that in 1996?
Ensure brevity in your answer.  1.04. What is the ratio of the Expenditure(as % of GDP) of Latin America(all income levels) in 1995 to that in 1997?
Ensure brevity in your answer.  1.11. What is the ratio of the Expenditure(as % of GDP) in Estonia in 1995 to that in 1997?
Your response must be concise. 0.86. What is the ratio of the Expenditure(as % of GDP) of Korea (Republic) in 1995 to that in 1997?
Offer a very short reply. 0.8. What is the ratio of the Expenditure(as % of GDP) in Mali in 1995 to that in 1997?
Make the answer very short. 1.22. What is the ratio of the Expenditure(as % of GDP) of Estonia in 1995 to that in 1998?
Provide a short and direct response. 0.62. What is the ratio of the Expenditure(as % of GDP) in Korea (Republic) in 1995 to that in 1998?
Make the answer very short. 0.42. What is the ratio of the Expenditure(as % of GDP) of Mali in 1995 to that in 1998?
Offer a very short reply. 1.43. What is the ratio of the Expenditure(as % of GDP) in Latin America(all income levels) in 1995 to that in 1999?
Your response must be concise. 0.8. What is the ratio of the Expenditure(as % of GDP) of Estonia in 1995 to that in 1999?
Provide a short and direct response. 0.73. What is the ratio of the Expenditure(as % of GDP) of Korea (Republic) in 1995 to that in 1999?
Your response must be concise. 0.65. What is the ratio of the Expenditure(as % of GDP) of Mali in 1995 to that in 1999?
Your answer should be very brief. 1.41. What is the ratio of the Expenditure(as % of GDP) of Latin America(all income levels) in 1995 to that in 2000?
Provide a short and direct response. 0.81. What is the ratio of the Expenditure(as % of GDP) of Estonia in 1995 to that in 2000?
Ensure brevity in your answer.  0.41. What is the ratio of the Expenditure(as % of GDP) in Korea (Republic) in 1995 to that in 2000?
Give a very brief answer. 0.72. What is the ratio of the Expenditure(as % of GDP) in Mali in 1995 to that in 2000?
Your answer should be very brief. 1.5. What is the ratio of the Expenditure(as % of GDP) in Latin America(all income levels) in 1995 to that in 2001?
Ensure brevity in your answer.  0.66. What is the ratio of the Expenditure(as % of GDP) of Estonia in 1995 to that in 2001?
Make the answer very short. 0.17. What is the ratio of the Expenditure(as % of GDP) in Korea (Republic) in 1995 to that in 2001?
Your response must be concise. 0.69. What is the ratio of the Expenditure(as % of GDP) of Mali in 1995 to that in 2001?
Make the answer very short. 1.42. What is the ratio of the Expenditure(as % of GDP) in Latin America(all income levels) in 1995 to that in 2002?
Offer a terse response. 0.51. What is the ratio of the Expenditure(as % of GDP) of Estonia in 1995 to that in 2002?
Give a very brief answer. 0.11. What is the ratio of the Expenditure(as % of GDP) of Korea (Republic) in 1995 to that in 2002?
Ensure brevity in your answer.  0.69. What is the ratio of the Expenditure(as % of GDP) in Mali in 1995 to that in 2002?
Make the answer very short. 0.96. What is the ratio of the Expenditure(as % of GDP) in Latin America(all income levels) in 1996 to that in 1997?
Your answer should be very brief. 1.04. What is the ratio of the Expenditure(as % of GDP) of Estonia in 1996 to that in 1997?
Your response must be concise. 1.03. What is the ratio of the Expenditure(as % of GDP) of Korea (Republic) in 1996 to that in 1997?
Make the answer very short. 0.77. What is the ratio of the Expenditure(as % of GDP) of Mali in 1996 to that in 1997?
Provide a succinct answer. 1.17. What is the ratio of the Expenditure(as % of GDP) in Latin America(all income levels) in 1996 to that in 1998?
Provide a short and direct response. 0.93. What is the ratio of the Expenditure(as % of GDP) of Estonia in 1996 to that in 1998?
Ensure brevity in your answer.  0.75. What is the ratio of the Expenditure(as % of GDP) in Korea (Republic) in 1996 to that in 1998?
Your answer should be compact. 0.4. What is the ratio of the Expenditure(as % of GDP) in Mali in 1996 to that in 1998?
Your answer should be compact. 1.38. What is the ratio of the Expenditure(as % of GDP) of Latin America(all income levels) in 1996 to that in 1999?
Your response must be concise. 0.75. What is the ratio of the Expenditure(as % of GDP) of Estonia in 1996 to that in 1999?
Make the answer very short. 0.88. What is the ratio of the Expenditure(as % of GDP) of Korea (Republic) in 1996 to that in 1999?
Keep it short and to the point. 0.62. What is the ratio of the Expenditure(as % of GDP) of Mali in 1996 to that in 1999?
Offer a terse response. 1.36. What is the ratio of the Expenditure(as % of GDP) of Latin America(all income levels) in 1996 to that in 2000?
Give a very brief answer. 0.76. What is the ratio of the Expenditure(as % of GDP) of Estonia in 1996 to that in 2000?
Provide a succinct answer. 0.5. What is the ratio of the Expenditure(as % of GDP) in Korea (Republic) in 1996 to that in 2000?
Keep it short and to the point. 0.7. What is the ratio of the Expenditure(as % of GDP) in Mali in 1996 to that in 2000?
Offer a very short reply. 1.45. What is the ratio of the Expenditure(as % of GDP) of Latin America(all income levels) in 1996 to that in 2001?
Offer a terse response. 0.61. What is the ratio of the Expenditure(as % of GDP) of Estonia in 1996 to that in 2001?
Your answer should be compact. 0.2. What is the ratio of the Expenditure(as % of GDP) of Korea (Republic) in 1996 to that in 2001?
Your answer should be very brief. 0.66. What is the ratio of the Expenditure(as % of GDP) in Mali in 1996 to that in 2001?
Ensure brevity in your answer.  1.36. What is the ratio of the Expenditure(as % of GDP) of Latin America(all income levels) in 1996 to that in 2002?
Keep it short and to the point. 0.47. What is the ratio of the Expenditure(as % of GDP) of Estonia in 1996 to that in 2002?
Keep it short and to the point. 0.14. What is the ratio of the Expenditure(as % of GDP) of Korea (Republic) in 1996 to that in 2002?
Ensure brevity in your answer.  0.66. What is the ratio of the Expenditure(as % of GDP) of Mali in 1996 to that in 2002?
Offer a terse response. 0.92. What is the ratio of the Expenditure(as % of GDP) in Latin America(all income levels) in 1997 to that in 1998?
Ensure brevity in your answer.  0.9. What is the ratio of the Expenditure(as % of GDP) in Estonia in 1997 to that in 1998?
Offer a terse response. 0.73. What is the ratio of the Expenditure(as % of GDP) in Korea (Republic) in 1997 to that in 1998?
Give a very brief answer. 0.52. What is the ratio of the Expenditure(as % of GDP) in Mali in 1997 to that in 1998?
Keep it short and to the point. 1.18. What is the ratio of the Expenditure(as % of GDP) of Latin America(all income levels) in 1997 to that in 1999?
Provide a succinct answer. 0.72. What is the ratio of the Expenditure(as % of GDP) of Estonia in 1997 to that in 1999?
Ensure brevity in your answer.  0.85. What is the ratio of the Expenditure(as % of GDP) of Korea (Republic) in 1997 to that in 1999?
Make the answer very short. 0.8. What is the ratio of the Expenditure(as % of GDP) of Mali in 1997 to that in 1999?
Offer a terse response. 1.16. What is the ratio of the Expenditure(as % of GDP) of Latin America(all income levels) in 1997 to that in 2000?
Provide a succinct answer. 0.73. What is the ratio of the Expenditure(as % of GDP) in Estonia in 1997 to that in 2000?
Ensure brevity in your answer.  0.48. What is the ratio of the Expenditure(as % of GDP) in Korea (Republic) in 1997 to that in 2000?
Make the answer very short. 0.9. What is the ratio of the Expenditure(as % of GDP) of Mali in 1997 to that in 2000?
Keep it short and to the point. 1.23. What is the ratio of the Expenditure(as % of GDP) in Latin America(all income levels) in 1997 to that in 2001?
Your response must be concise. 0.59. What is the ratio of the Expenditure(as % of GDP) of Estonia in 1997 to that in 2001?
Provide a short and direct response. 0.19. What is the ratio of the Expenditure(as % of GDP) of Korea (Republic) in 1997 to that in 2001?
Offer a terse response. 0.86. What is the ratio of the Expenditure(as % of GDP) of Mali in 1997 to that in 2001?
Give a very brief answer. 1.16. What is the ratio of the Expenditure(as % of GDP) in Latin America(all income levels) in 1997 to that in 2002?
Your answer should be very brief. 0.46. What is the ratio of the Expenditure(as % of GDP) of Estonia in 1997 to that in 2002?
Keep it short and to the point. 0.13. What is the ratio of the Expenditure(as % of GDP) in Korea (Republic) in 1997 to that in 2002?
Your answer should be very brief. 0.86. What is the ratio of the Expenditure(as % of GDP) in Mali in 1997 to that in 2002?
Offer a terse response. 0.79. What is the ratio of the Expenditure(as % of GDP) in Latin America(all income levels) in 1998 to that in 1999?
Provide a succinct answer. 0.8. What is the ratio of the Expenditure(as % of GDP) in Estonia in 1998 to that in 1999?
Provide a short and direct response. 1.16. What is the ratio of the Expenditure(as % of GDP) of Korea (Republic) in 1998 to that in 1999?
Give a very brief answer. 1.54. What is the ratio of the Expenditure(as % of GDP) in Mali in 1998 to that in 1999?
Make the answer very short. 0.98. What is the ratio of the Expenditure(as % of GDP) of Latin America(all income levels) in 1998 to that in 2000?
Offer a very short reply. 0.81. What is the ratio of the Expenditure(as % of GDP) of Estonia in 1998 to that in 2000?
Offer a very short reply. 0.66. What is the ratio of the Expenditure(as % of GDP) of Korea (Republic) in 1998 to that in 2000?
Your answer should be very brief. 1.72. What is the ratio of the Expenditure(as % of GDP) in Mali in 1998 to that in 2000?
Offer a very short reply. 1.05. What is the ratio of the Expenditure(as % of GDP) of Latin America(all income levels) in 1998 to that in 2001?
Ensure brevity in your answer.  0.66. What is the ratio of the Expenditure(as % of GDP) in Estonia in 1998 to that in 2001?
Make the answer very short. 0.27. What is the ratio of the Expenditure(as % of GDP) in Korea (Republic) in 1998 to that in 2001?
Ensure brevity in your answer.  1.64. What is the ratio of the Expenditure(as % of GDP) in Latin America(all income levels) in 1998 to that in 2002?
Give a very brief answer. 0.51. What is the ratio of the Expenditure(as % of GDP) of Estonia in 1998 to that in 2002?
Keep it short and to the point. 0.18. What is the ratio of the Expenditure(as % of GDP) in Korea (Republic) in 1998 to that in 2002?
Your answer should be compact. 1.64. What is the ratio of the Expenditure(as % of GDP) in Mali in 1998 to that in 2002?
Provide a succinct answer. 0.67. What is the ratio of the Expenditure(as % of GDP) in Latin America(all income levels) in 1999 to that in 2000?
Provide a short and direct response. 1.01. What is the ratio of the Expenditure(as % of GDP) of Estonia in 1999 to that in 2000?
Give a very brief answer. 0.57. What is the ratio of the Expenditure(as % of GDP) of Korea (Republic) in 1999 to that in 2000?
Your response must be concise. 1.12. What is the ratio of the Expenditure(as % of GDP) of Mali in 1999 to that in 2000?
Provide a succinct answer. 1.07. What is the ratio of the Expenditure(as % of GDP) in Latin America(all income levels) in 1999 to that in 2001?
Your answer should be very brief. 0.82. What is the ratio of the Expenditure(as % of GDP) in Estonia in 1999 to that in 2001?
Give a very brief answer. 0.23. What is the ratio of the Expenditure(as % of GDP) in Korea (Republic) in 1999 to that in 2001?
Provide a succinct answer. 1.07. What is the ratio of the Expenditure(as % of GDP) of Latin America(all income levels) in 1999 to that in 2002?
Provide a short and direct response. 0.63. What is the ratio of the Expenditure(as % of GDP) in Estonia in 1999 to that in 2002?
Your answer should be compact. 0.15. What is the ratio of the Expenditure(as % of GDP) of Korea (Republic) in 1999 to that in 2002?
Keep it short and to the point. 1.07. What is the ratio of the Expenditure(as % of GDP) of Mali in 1999 to that in 2002?
Offer a very short reply. 0.68. What is the ratio of the Expenditure(as % of GDP) in Latin America(all income levels) in 2000 to that in 2001?
Your answer should be compact. 0.81. What is the ratio of the Expenditure(as % of GDP) of Estonia in 2000 to that in 2001?
Provide a short and direct response. 0.4. What is the ratio of the Expenditure(as % of GDP) in Korea (Republic) in 2000 to that in 2001?
Provide a succinct answer. 0.95. What is the ratio of the Expenditure(as % of GDP) in Mali in 2000 to that in 2001?
Give a very brief answer. 0.94. What is the ratio of the Expenditure(as % of GDP) in Latin America(all income levels) in 2000 to that in 2002?
Your answer should be very brief. 0.62. What is the ratio of the Expenditure(as % of GDP) in Estonia in 2000 to that in 2002?
Provide a succinct answer. 0.27. What is the ratio of the Expenditure(as % of GDP) in Korea (Republic) in 2000 to that in 2002?
Your answer should be very brief. 0.95. What is the ratio of the Expenditure(as % of GDP) in Mali in 2000 to that in 2002?
Make the answer very short. 0.64. What is the ratio of the Expenditure(as % of GDP) in Latin America(all income levels) in 2001 to that in 2002?
Provide a short and direct response. 0.77. What is the ratio of the Expenditure(as % of GDP) in Estonia in 2001 to that in 2002?
Provide a succinct answer. 0.67. What is the ratio of the Expenditure(as % of GDP) in Mali in 2001 to that in 2002?
Ensure brevity in your answer.  0.68. What is the difference between the highest and the second highest Expenditure(as % of GDP) of Latin America(all income levels)?
Keep it short and to the point. 0.35. What is the difference between the highest and the second highest Expenditure(as % of GDP) of Estonia?
Ensure brevity in your answer.  0.09. What is the difference between the highest and the second highest Expenditure(as % of GDP) in Korea (Republic)?
Offer a terse response. 0.52. What is the difference between the highest and the second highest Expenditure(as % of GDP) of Mali?
Ensure brevity in your answer.  0.17. What is the difference between the highest and the lowest Expenditure(as % of GDP) of Latin America(all income levels)?
Give a very brief answer. 0.83. What is the difference between the highest and the lowest Expenditure(as % of GDP) in Estonia?
Provide a succinct answer. 0.23. What is the difference between the highest and the lowest Expenditure(as % of GDP) of Korea (Republic)?
Your response must be concise. 0.89. What is the difference between the highest and the lowest Expenditure(as % of GDP) in Mali?
Offer a terse response. 1.56. 